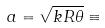Convert formula to latex. <formula><loc_0><loc_0><loc_500><loc_500>a = \sqrt { k R \theta } \equiv</formula> 